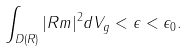Convert formula to latex. <formula><loc_0><loc_0><loc_500><loc_500>\int _ { D ( R ) } | R m | ^ { 2 } d V _ { g } < \epsilon < \epsilon _ { 0 } .</formula> 